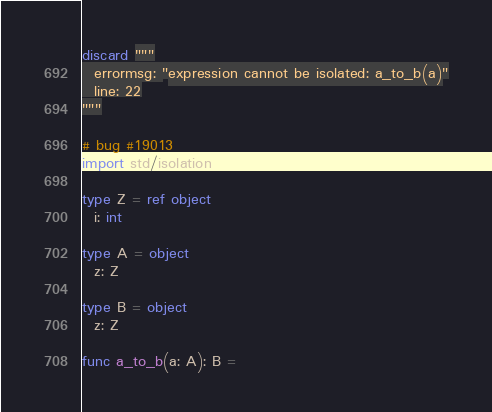<code> <loc_0><loc_0><loc_500><loc_500><_Nim_>discard """
  errormsg: "expression cannot be isolated: a_to_b(a)"
  line: 22
"""

# bug #19013
import std/isolation

type Z = ref object
  i: int

type A = object
  z: Z

type B = object
  z: Z

func a_to_b(a: A): B =</code> 